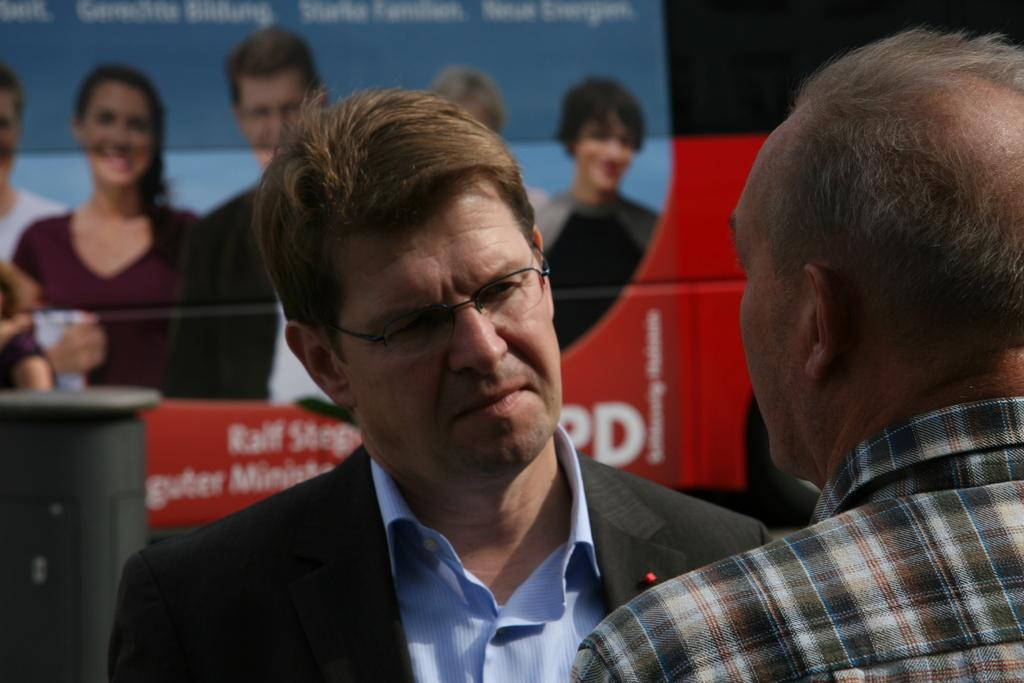How many people are present in the image? There are two people standing in the image. What can be seen behind the people? There is a banner visible behind the people. What type of cactus is being cared for by the parent in the image? There is no cactus or parent present in the image. 